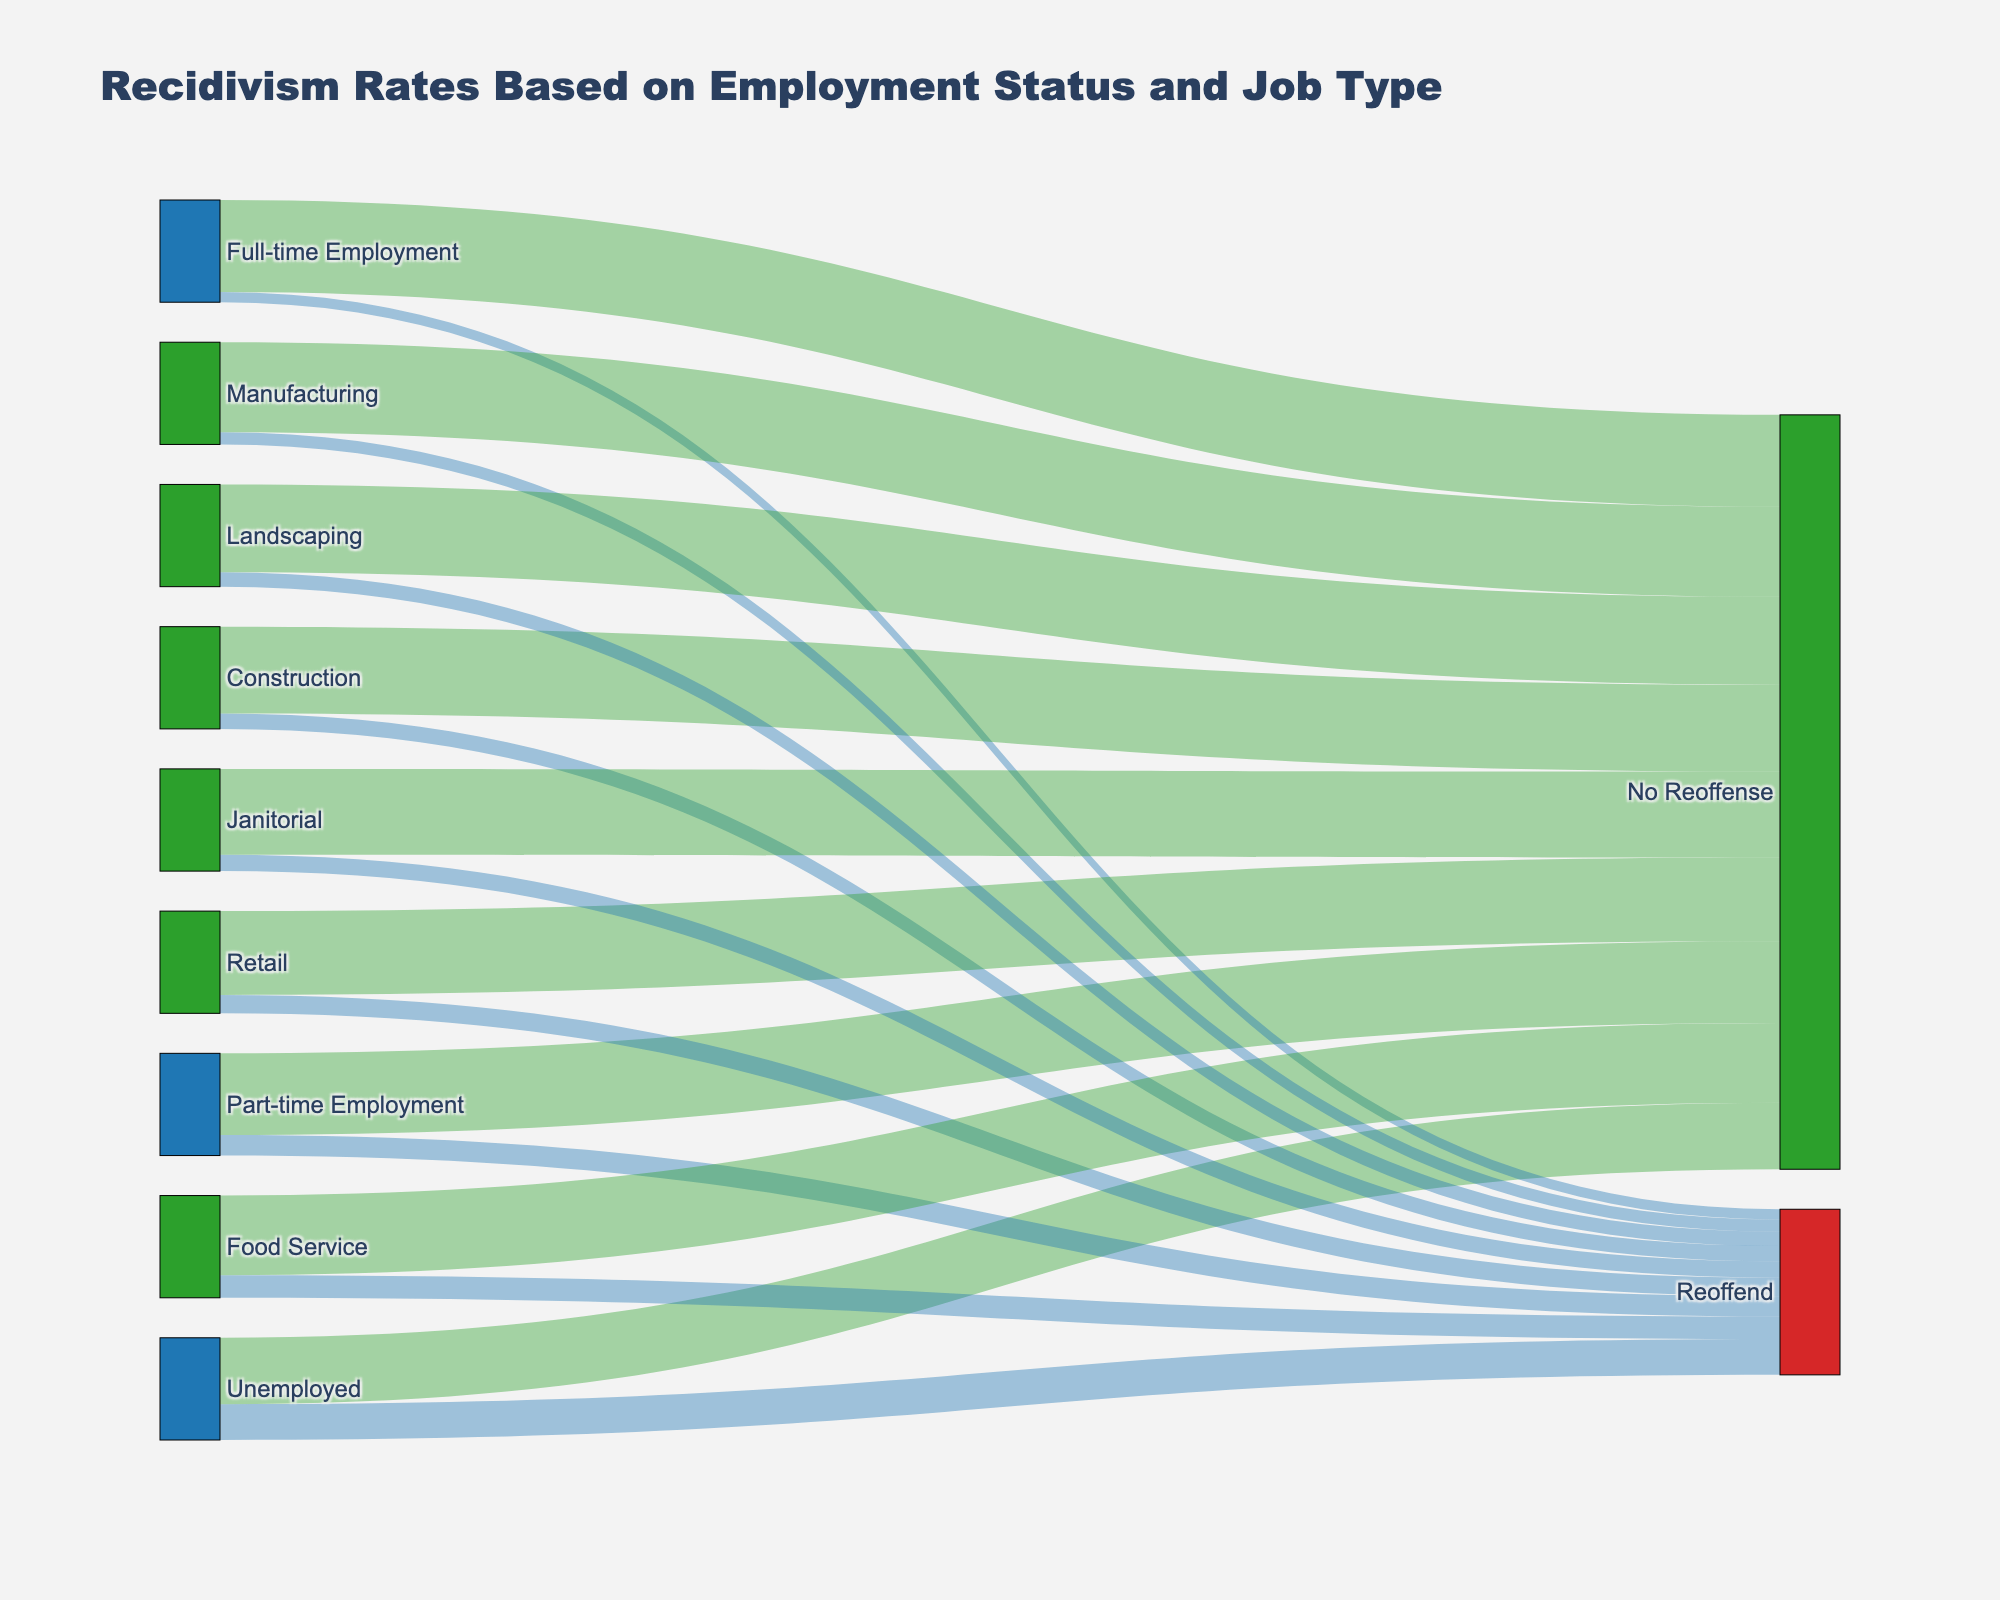What is the title of the figure? The title is typically displayed at the top of the figure and provides a clear summary of what the figure represents.
Answer: Recidivism Rates Based on Employment Status and Job Type How many different employment statuses are displayed in the figure? The employment statuses can be identified by looking at the nodes in the diagram that are connected to the 'Reoffend' and 'No Reoffense' nodes.
Answer: Three (Unemployed, Part-time Employment, Full-time Employment) Which type of employment has the highest number of people who reoffended? Compare the values of reoffending rates linked with each employment status to find the highest one.
Answer: Unemployed What is the reoffending rate for those employed in retail jobs? Refer to the links connecting 'Retail' to 'Reoffend' and note the value.
Answer: 18% How does the reoffending rate for those with full-time employment compare to those with part-time employment? Look at the values connecting 'Full-time Employment' and 'Part-time Employment' to 'Reoffend' and compare them.
Answer: Lower for full-time employment What is the most common outcome for individuals who are unemployed? Observe the values connecting 'Unemployed' to 'Reoffend' and 'No Reoffense' and identify the higher value.
Answer: No Reoffense What is the total number of people who reoffended? Sum up the values for 'Reoffend' across all sources.
Answer: 132 What is the difference in reoffending rates between food service and manufacturing jobs? Subtract the reoffending rate of those in manufacturing from that of those in food service.
Answer: 10% Which job category has the highest rate of no reoffense? Compare the values connected from job categories to 'No Reoffense' and identify the highest one.
Answer: Manufacturing How does the overall no-reoffense rate for unemployed individuals compare to those with full-time employment? Compare the value of 'No Reoffense' for 'Unemployed' and 'Full-time Employment' nodes.
Answer: Lower for unemployed 